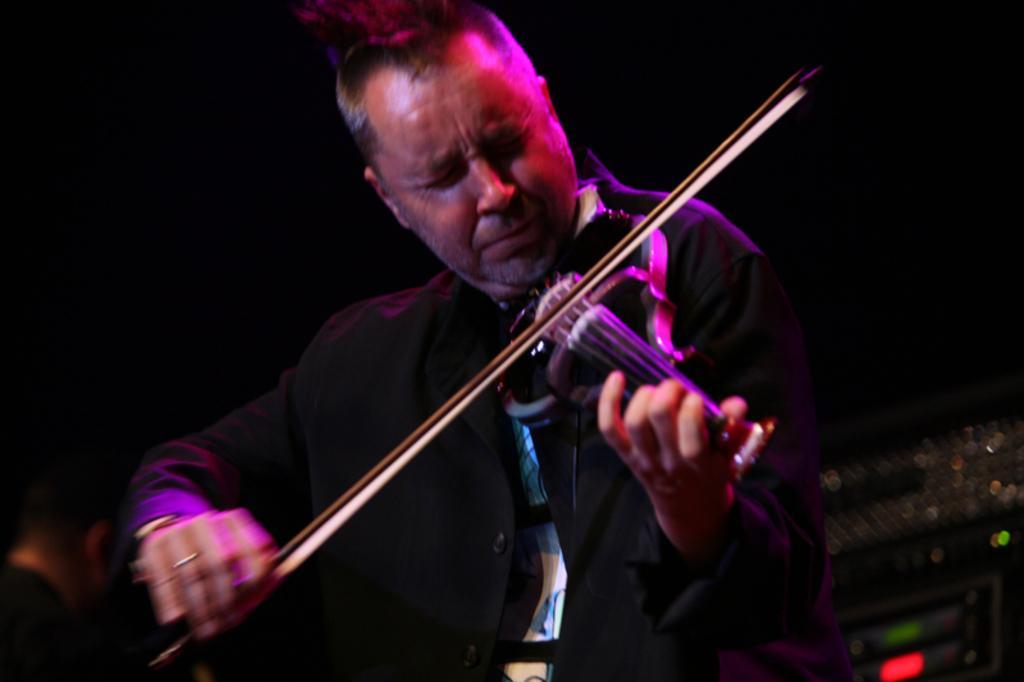Could you give a brief overview of what you see in this image? This picture seems to be clicked inside. In the foreground there is a man wearing black color shirt and playing violin and seems to be sitting on the chair. The background of the image is very dark and we can see some musical instruments. 